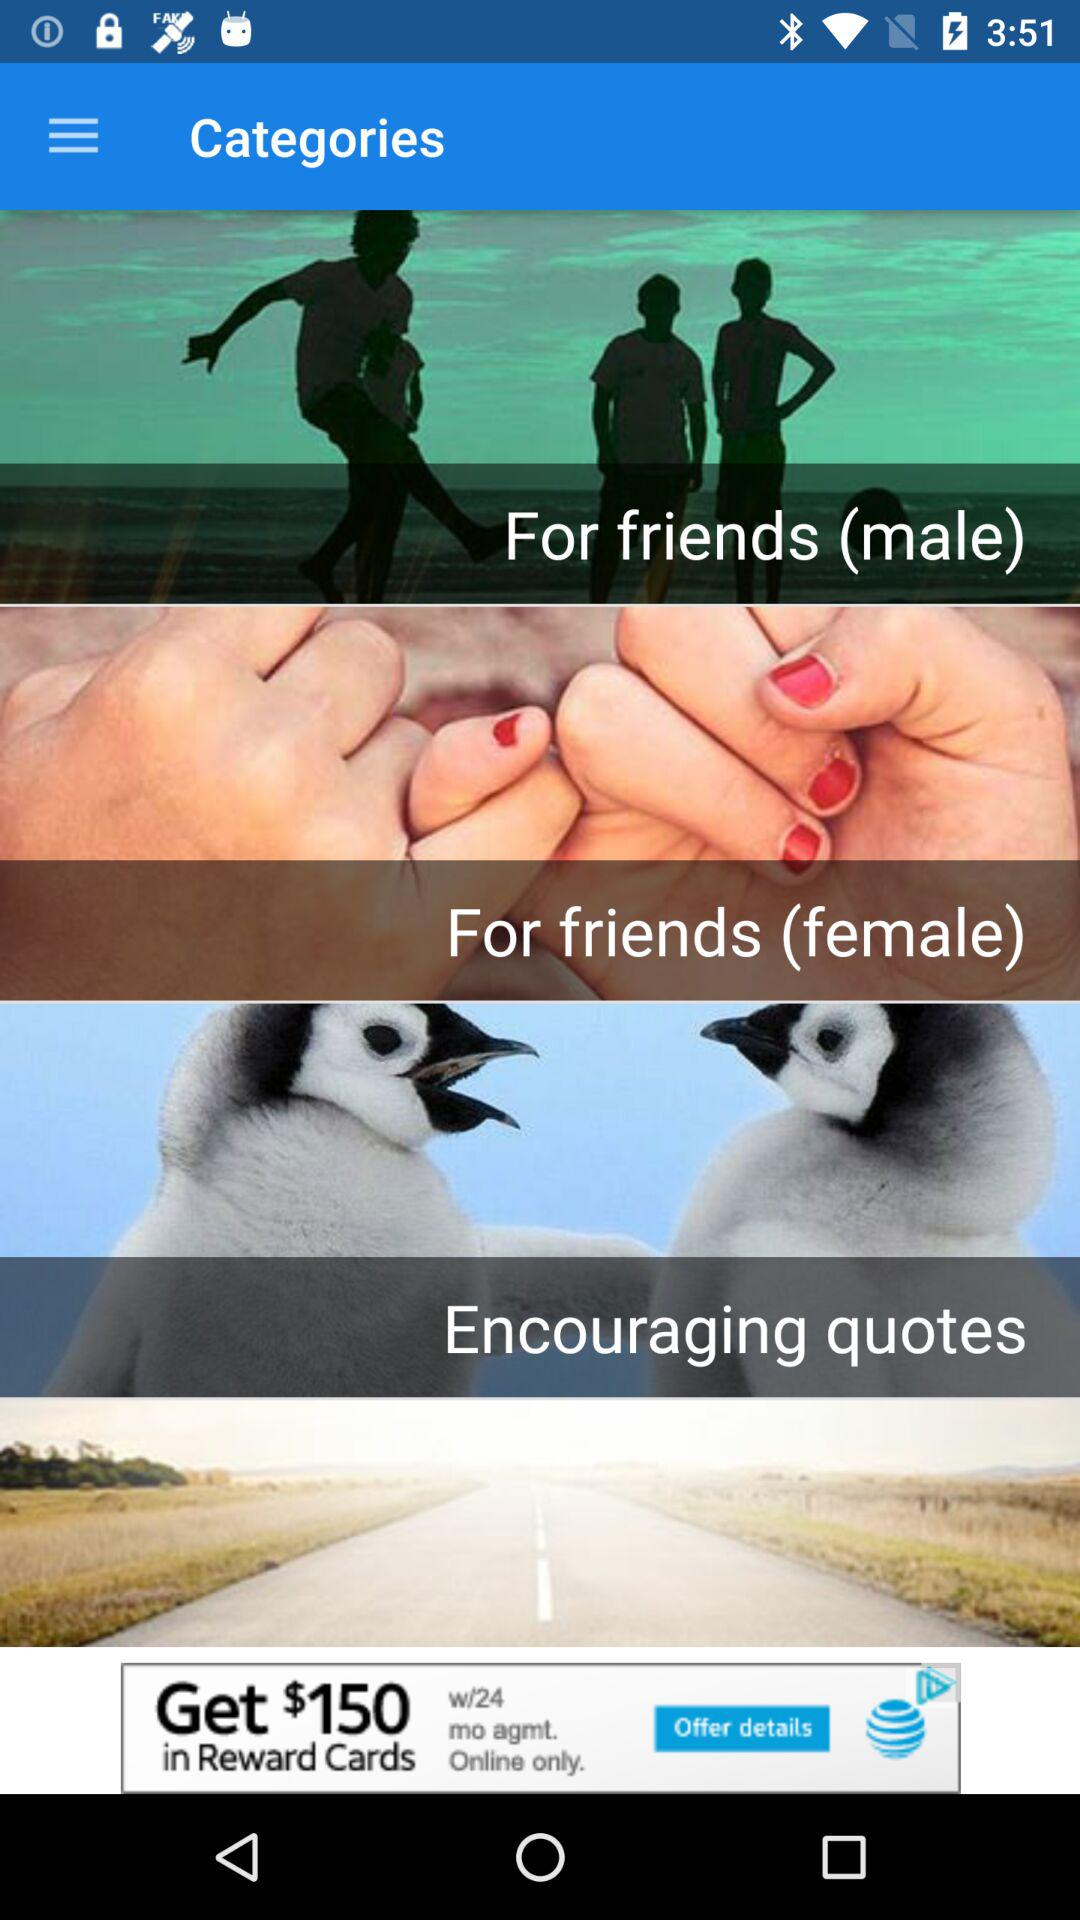Which encouraging quotes are available?
When the provided information is insufficient, respond with <no answer>. <no answer> 